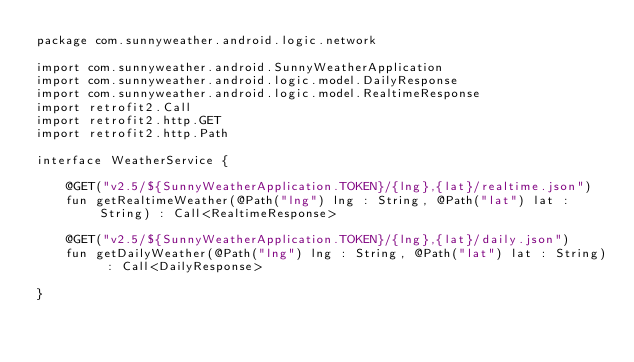<code> <loc_0><loc_0><loc_500><loc_500><_Kotlin_>package com.sunnyweather.android.logic.network

import com.sunnyweather.android.SunnyWeatherApplication
import com.sunnyweather.android.logic.model.DailyResponse
import com.sunnyweather.android.logic.model.RealtimeResponse
import retrofit2.Call
import retrofit2.http.GET
import retrofit2.http.Path

interface WeatherService {

    @GET("v2.5/${SunnyWeatherApplication.TOKEN}/{lng},{lat}/realtime.json")
    fun getRealtimeWeather(@Path("lng") lng : String, @Path("lat") lat : String) : Call<RealtimeResponse>

    @GET("v2.5/${SunnyWeatherApplication.TOKEN}/{lng},{lat}/daily.json")
    fun getDailyWeather(@Path("lng") lng : String, @Path("lat") lat : String) : Call<DailyResponse>

}</code> 